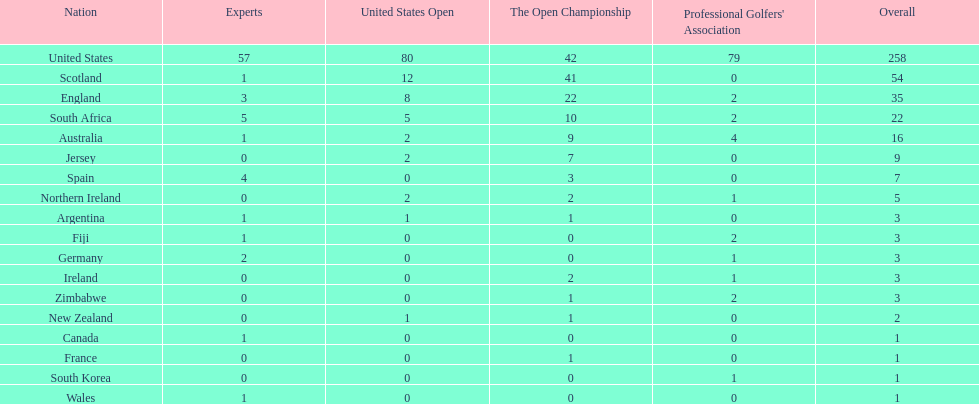What is the count of zimbabwean golfers who have achieved pga victories? 2. 